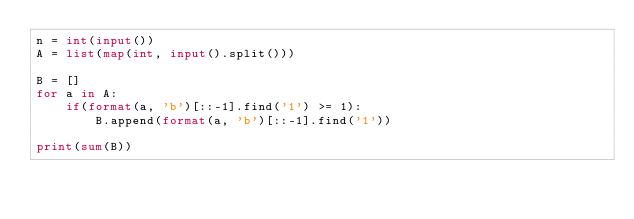<code> <loc_0><loc_0><loc_500><loc_500><_Python_>n = int(input())
A = list(map(int, input().split()))

B = []
for a in A:
    if(format(a, 'b')[::-1].find('1') >= 1):
        B.append(format(a, 'b')[::-1].find('1'))

print(sum(B))</code> 